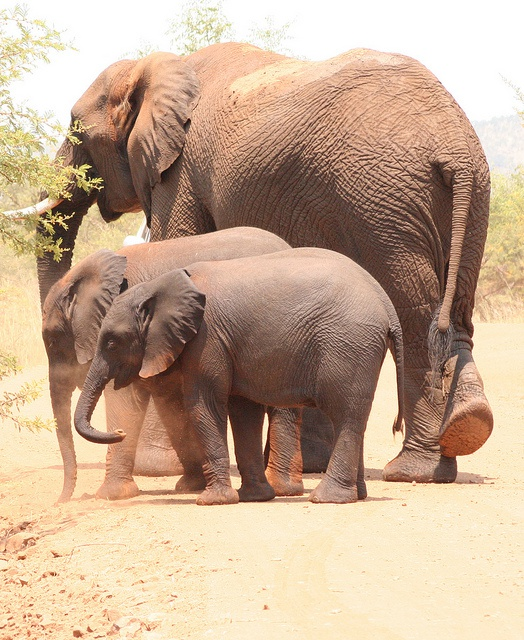Describe the objects in this image and their specific colors. I can see elephant in white, tan, maroon, and gray tones, elephant in white, maroon, gray, brown, and tan tones, and elephant in white, tan, and gray tones in this image. 